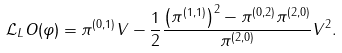Convert formula to latex. <formula><loc_0><loc_0><loc_500><loc_500>\mathcal { L } _ { L } O ( \varphi ) = \pi ^ { ( 0 , 1 ) } V - \frac { 1 } { 2 } \frac { \left ( \pi ^ { ( 1 , 1 ) } \right ) ^ { 2 } - \pi ^ { ( 0 , 2 ) } \pi ^ { ( 2 , 0 ) } } { \pi ^ { ( 2 , 0 ) } } V ^ { 2 } .</formula> 